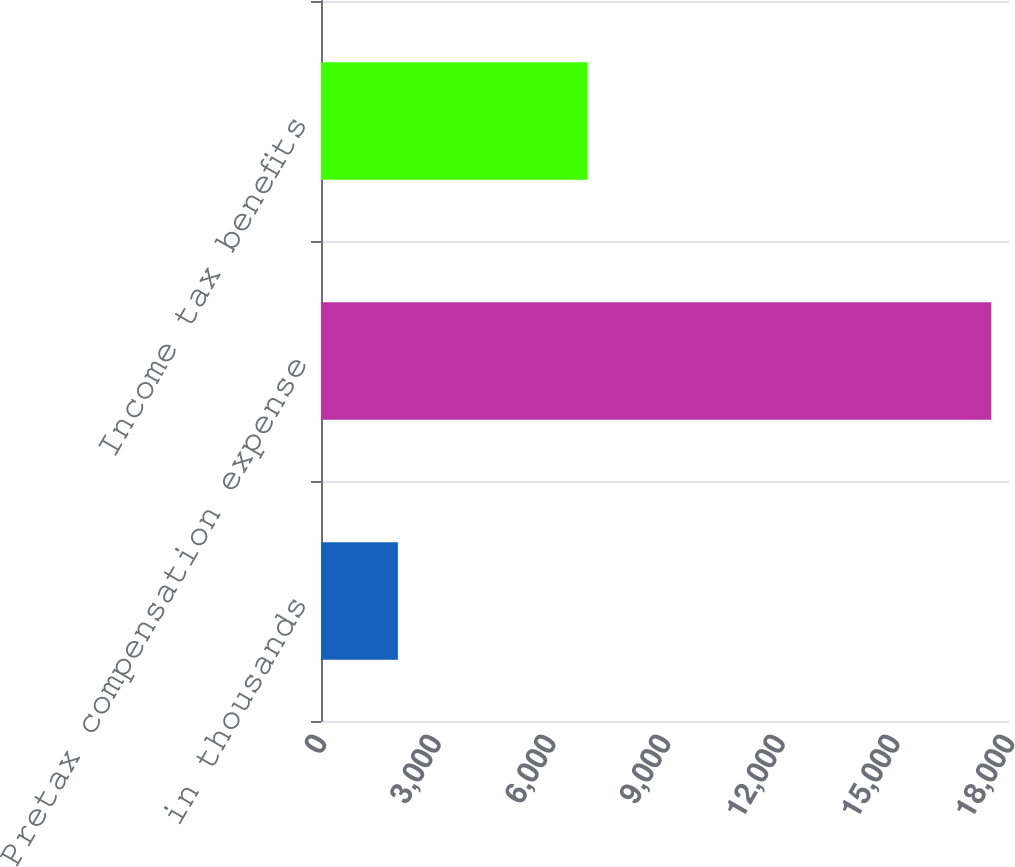Convert chart to OTSL. <chart><loc_0><loc_0><loc_500><loc_500><bar_chart><fcel>in thousands<fcel>Pretax compensation expense<fcel>Income tax benefits<nl><fcel>2011<fcel>17537<fcel>6976<nl></chart> 